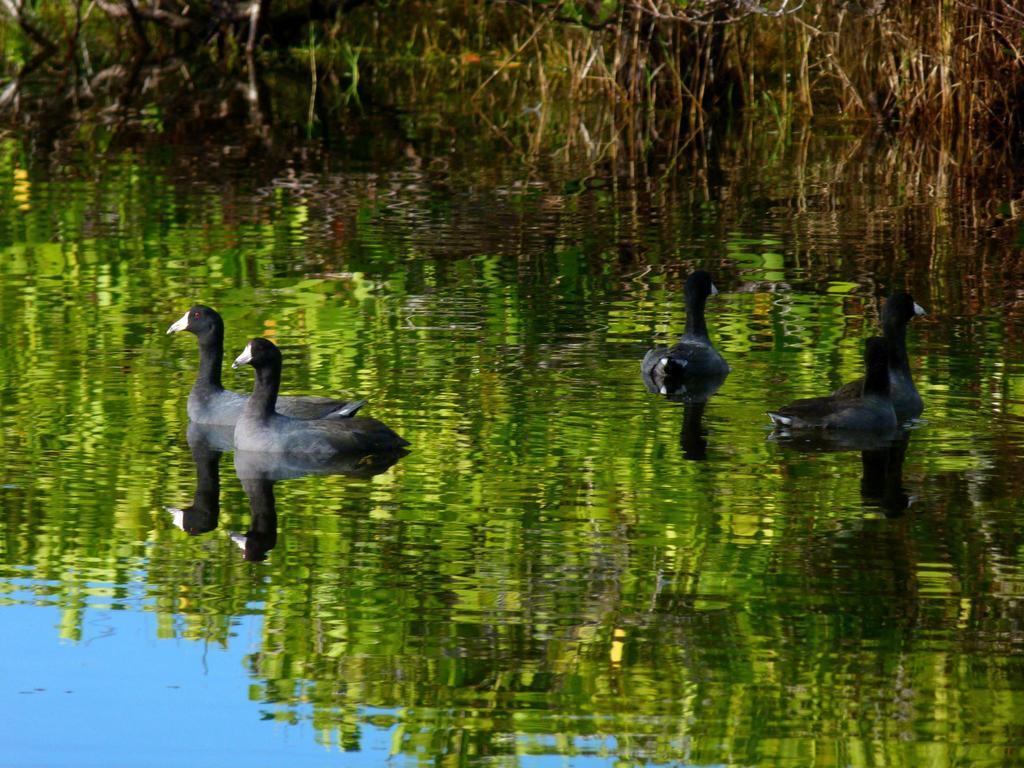How would you summarize this image in a sentence or two? In this picture we can see some four black and grey color ducks are swimming in the small water pound. Behind there is some dry grass. 